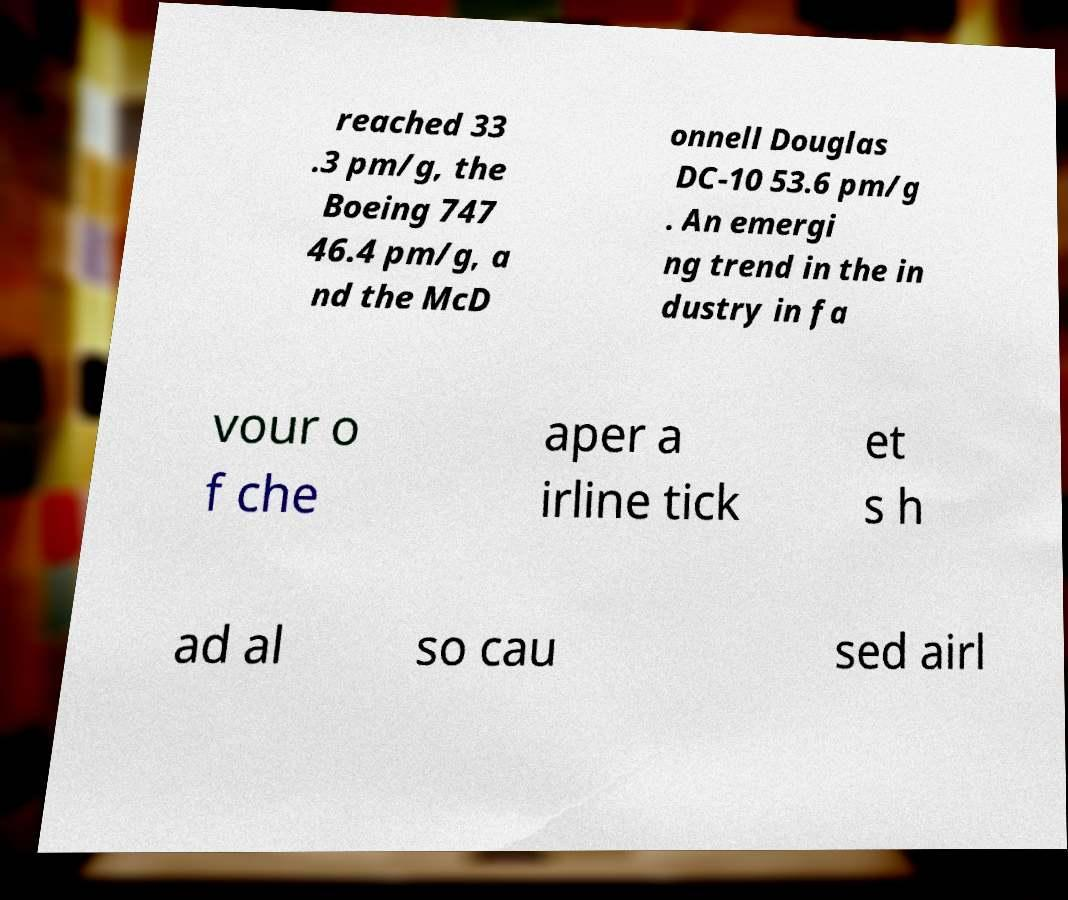What messages or text are displayed in this image? I need them in a readable, typed format. reached 33 .3 pm/g, the Boeing 747 46.4 pm/g, a nd the McD onnell Douglas DC-10 53.6 pm/g . An emergi ng trend in the in dustry in fa vour o f che aper a irline tick et s h ad al so cau sed airl 